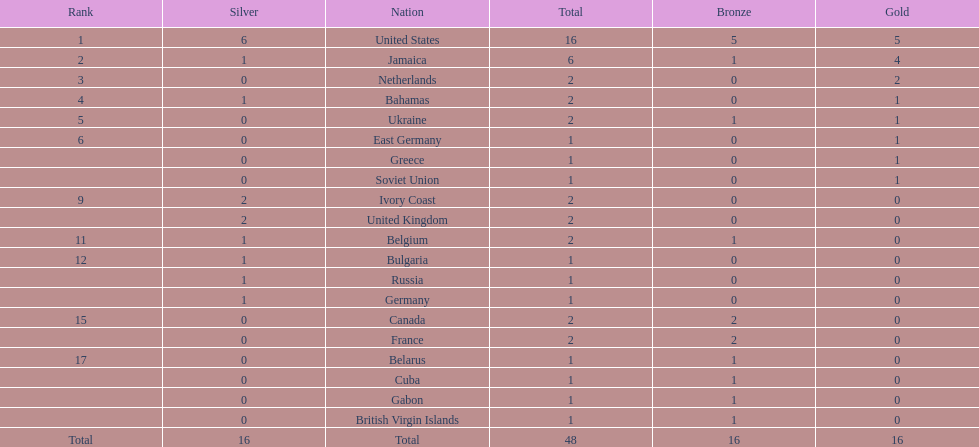What number of nations received 1 medal? 10. 